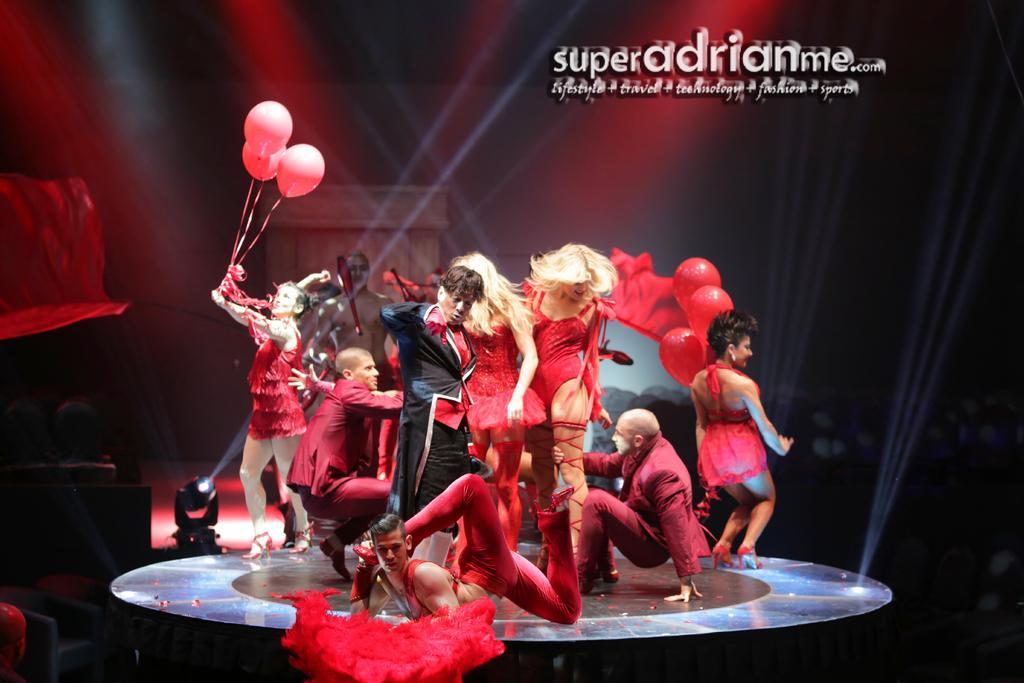Can you describe this image briefly? It is an edited image, there are many people performing some activities on a floor and most of them are wearing red costume and the background of them is blurry, on the top right there is some text. 